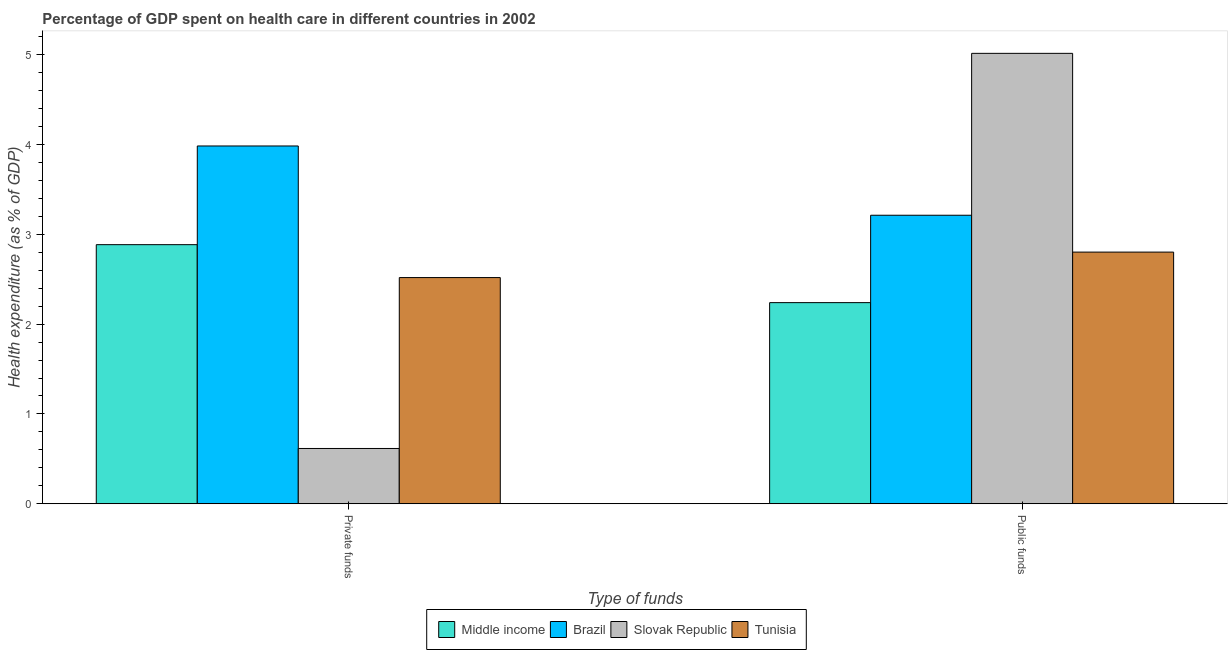How many groups of bars are there?
Provide a short and direct response. 2. Are the number of bars on each tick of the X-axis equal?
Your answer should be compact. Yes. How many bars are there on the 1st tick from the left?
Make the answer very short. 4. What is the label of the 1st group of bars from the left?
Provide a short and direct response. Private funds. What is the amount of private funds spent in healthcare in Middle income?
Provide a succinct answer. 2.88. Across all countries, what is the maximum amount of private funds spent in healthcare?
Provide a succinct answer. 3.98. Across all countries, what is the minimum amount of private funds spent in healthcare?
Ensure brevity in your answer.  0.62. In which country was the amount of public funds spent in healthcare maximum?
Your answer should be compact. Slovak Republic. In which country was the amount of public funds spent in healthcare minimum?
Give a very brief answer. Middle income. What is the total amount of public funds spent in healthcare in the graph?
Offer a very short reply. 13.27. What is the difference between the amount of private funds spent in healthcare in Slovak Republic and that in Middle income?
Ensure brevity in your answer.  -2.27. What is the difference between the amount of private funds spent in healthcare in Slovak Republic and the amount of public funds spent in healthcare in Brazil?
Offer a very short reply. -2.6. What is the average amount of public funds spent in healthcare per country?
Provide a succinct answer. 3.32. What is the difference between the amount of public funds spent in healthcare and amount of private funds spent in healthcare in Slovak Republic?
Offer a terse response. 4.4. What is the ratio of the amount of private funds spent in healthcare in Middle income to that in Tunisia?
Make the answer very short. 1.15. Is the amount of public funds spent in healthcare in Slovak Republic less than that in Tunisia?
Keep it short and to the point. No. In how many countries, is the amount of private funds spent in healthcare greater than the average amount of private funds spent in healthcare taken over all countries?
Your answer should be very brief. 3. What does the 2nd bar from the left in Private funds represents?
Ensure brevity in your answer.  Brazil. What does the 1st bar from the right in Private funds represents?
Offer a terse response. Tunisia. How many bars are there?
Give a very brief answer. 8. How many countries are there in the graph?
Your response must be concise. 4. What is the difference between two consecutive major ticks on the Y-axis?
Your answer should be compact. 1. Are the values on the major ticks of Y-axis written in scientific E-notation?
Make the answer very short. No. Does the graph contain any zero values?
Make the answer very short. No. Does the graph contain grids?
Provide a succinct answer. No. How are the legend labels stacked?
Provide a succinct answer. Horizontal. What is the title of the graph?
Offer a terse response. Percentage of GDP spent on health care in different countries in 2002. Does "Kyrgyz Republic" appear as one of the legend labels in the graph?
Give a very brief answer. No. What is the label or title of the X-axis?
Provide a succinct answer. Type of funds. What is the label or title of the Y-axis?
Keep it short and to the point. Health expenditure (as % of GDP). What is the Health expenditure (as % of GDP) in Middle income in Private funds?
Make the answer very short. 2.88. What is the Health expenditure (as % of GDP) in Brazil in Private funds?
Make the answer very short. 3.98. What is the Health expenditure (as % of GDP) of Slovak Republic in Private funds?
Keep it short and to the point. 0.62. What is the Health expenditure (as % of GDP) in Tunisia in Private funds?
Keep it short and to the point. 2.52. What is the Health expenditure (as % of GDP) of Middle income in Public funds?
Your answer should be very brief. 2.24. What is the Health expenditure (as % of GDP) of Brazil in Public funds?
Ensure brevity in your answer.  3.21. What is the Health expenditure (as % of GDP) in Slovak Republic in Public funds?
Provide a short and direct response. 5.01. What is the Health expenditure (as % of GDP) of Tunisia in Public funds?
Your answer should be compact. 2.8. Across all Type of funds, what is the maximum Health expenditure (as % of GDP) of Middle income?
Your answer should be compact. 2.88. Across all Type of funds, what is the maximum Health expenditure (as % of GDP) in Brazil?
Offer a very short reply. 3.98. Across all Type of funds, what is the maximum Health expenditure (as % of GDP) of Slovak Republic?
Your answer should be very brief. 5.01. Across all Type of funds, what is the maximum Health expenditure (as % of GDP) of Tunisia?
Offer a terse response. 2.8. Across all Type of funds, what is the minimum Health expenditure (as % of GDP) of Middle income?
Keep it short and to the point. 2.24. Across all Type of funds, what is the minimum Health expenditure (as % of GDP) of Brazil?
Your answer should be very brief. 3.21. Across all Type of funds, what is the minimum Health expenditure (as % of GDP) in Slovak Republic?
Keep it short and to the point. 0.62. Across all Type of funds, what is the minimum Health expenditure (as % of GDP) in Tunisia?
Your response must be concise. 2.52. What is the total Health expenditure (as % of GDP) in Middle income in the graph?
Your answer should be very brief. 5.12. What is the total Health expenditure (as % of GDP) of Brazil in the graph?
Provide a succinct answer. 7.19. What is the total Health expenditure (as % of GDP) of Slovak Republic in the graph?
Your answer should be very brief. 5.63. What is the total Health expenditure (as % of GDP) of Tunisia in the graph?
Offer a very short reply. 5.32. What is the difference between the Health expenditure (as % of GDP) in Middle income in Private funds and that in Public funds?
Keep it short and to the point. 0.65. What is the difference between the Health expenditure (as % of GDP) of Brazil in Private funds and that in Public funds?
Provide a succinct answer. 0.77. What is the difference between the Health expenditure (as % of GDP) in Slovak Republic in Private funds and that in Public funds?
Give a very brief answer. -4.4. What is the difference between the Health expenditure (as % of GDP) in Tunisia in Private funds and that in Public funds?
Your response must be concise. -0.28. What is the difference between the Health expenditure (as % of GDP) of Middle income in Private funds and the Health expenditure (as % of GDP) of Brazil in Public funds?
Make the answer very short. -0.33. What is the difference between the Health expenditure (as % of GDP) of Middle income in Private funds and the Health expenditure (as % of GDP) of Slovak Republic in Public funds?
Offer a very short reply. -2.13. What is the difference between the Health expenditure (as % of GDP) of Middle income in Private funds and the Health expenditure (as % of GDP) of Tunisia in Public funds?
Provide a short and direct response. 0.08. What is the difference between the Health expenditure (as % of GDP) in Brazil in Private funds and the Health expenditure (as % of GDP) in Slovak Republic in Public funds?
Your response must be concise. -1.03. What is the difference between the Health expenditure (as % of GDP) of Brazil in Private funds and the Health expenditure (as % of GDP) of Tunisia in Public funds?
Offer a terse response. 1.18. What is the difference between the Health expenditure (as % of GDP) of Slovak Republic in Private funds and the Health expenditure (as % of GDP) of Tunisia in Public funds?
Ensure brevity in your answer.  -2.19. What is the average Health expenditure (as % of GDP) of Middle income per Type of funds?
Provide a succinct answer. 2.56. What is the average Health expenditure (as % of GDP) in Brazil per Type of funds?
Provide a succinct answer. 3.6. What is the average Health expenditure (as % of GDP) of Slovak Republic per Type of funds?
Make the answer very short. 2.81. What is the average Health expenditure (as % of GDP) in Tunisia per Type of funds?
Provide a succinct answer. 2.66. What is the difference between the Health expenditure (as % of GDP) of Middle income and Health expenditure (as % of GDP) of Brazil in Private funds?
Ensure brevity in your answer.  -1.1. What is the difference between the Health expenditure (as % of GDP) in Middle income and Health expenditure (as % of GDP) in Slovak Republic in Private funds?
Give a very brief answer. 2.27. What is the difference between the Health expenditure (as % of GDP) of Middle income and Health expenditure (as % of GDP) of Tunisia in Private funds?
Make the answer very short. 0.37. What is the difference between the Health expenditure (as % of GDP) of Brazil and Health expenditure (as % of GDP) of Slovak Republic in Private funds?
Your response must be concise. 3.37. What is the difference between the Health expenditure (as % of GDP) of Brazil and Health expenditure (as % of GDP) of Tunisia in Private funds?
Your answer should be very brief. 1.46. What is the difference between the Health expenditure (as % of GDP) in Slovak Republic and Health expenditure (as % of GDP) in Tunisia in Private funds?
Provide a short and direct response. -1.9. What is the difference between the Health expenditure (as % of GDP) of Middle income and Health expenditure (as % of GDP) of Brazil in Public funds?
Your answer should be compact. -0.97. What is the difference between the Health expenditure (as % of GDP) in Middle income and Health expenditure (as % of GDP) in Slovak Republic in Public funds?
Give a very brief answer. -2.77. What is the difference between the Health expenditure (as % of GDP) in Middle income and Health expenditure (as % of GDP) in Tunisia in Public funds?
Offer a terse response. -0.56. What is the difference between the Health expenditure (as % of GDP) in Brazil and Health expenditure (as % of GDP) in Slovak Republic in Public funds?
Ensure brevity in your answer.  -1.8. What is the difference between the Health expenditure (as % of GDP) in Brazil and Health expenditure (as % of GDP) in Tunisia in Public funds?
Give a very brief answer. 0.41. What is the difference between the Health expenditure (as % of GDP) in Slovak Republic and Health expenditure (as % of GDP) in Tunisia in Public funds?
Offer a terse response. 2.21. What is the ratio of the Health expenditure (as % of GDP) of Middle income in Private funds to that in Public funds?
Your answer should be very brief. 1.29. What is the ratio of the Health expenditure (as % of GDP) of Brazil in Private funds to that in Public funds?
Provide a short and direct response. 1.24. What is the ratio of the Health expenditure (as % of GDP) of Slovak Republic in Private funds to that in Public funds?
Your answer should be compact. 0.12. What is the ratio of the Health expenditure (as % of GDP) of Tunisia in Private funds to that in Public funds?
Ensure brevity in your answer.  0.9. What is the difference between the highest and the second highest Health expenditure (as % of GDP) in Middle income?
Offer a terse response. 0.65. What is the difference between the highest and the second highest Health expenditure (as % of GDP) in Brazil?
Provide a short and direct response. 0.77. What is the difference between the highest and the second highest Health expenditure (as % of GDP) in Slovak Republic?
Your response must be concise. 4.4. What is the difference between the highest and the second highest Health expenditure (as % of GDP) in Tunisia?
Your answer should be compact. 0.28. What is the difference between the highest and the lowest Health expenditure (as % of GDP) of Middle income?
Your answer should be compact. 0.65. What is the difference between the highest and the lowest Health expenditure (as % of GDP) of Brazil?
Offer a very short reply. 0.77. What is the difference between the highest and the lowest Health expenditure (as % of GDP) in Slovak Republic?
Make the answer very short. 4.4. What is the difference between the highest and the lowest Health expenditure (as % of GDP) in Tunisia?
Ensure brevity in your answer.  0.28. 